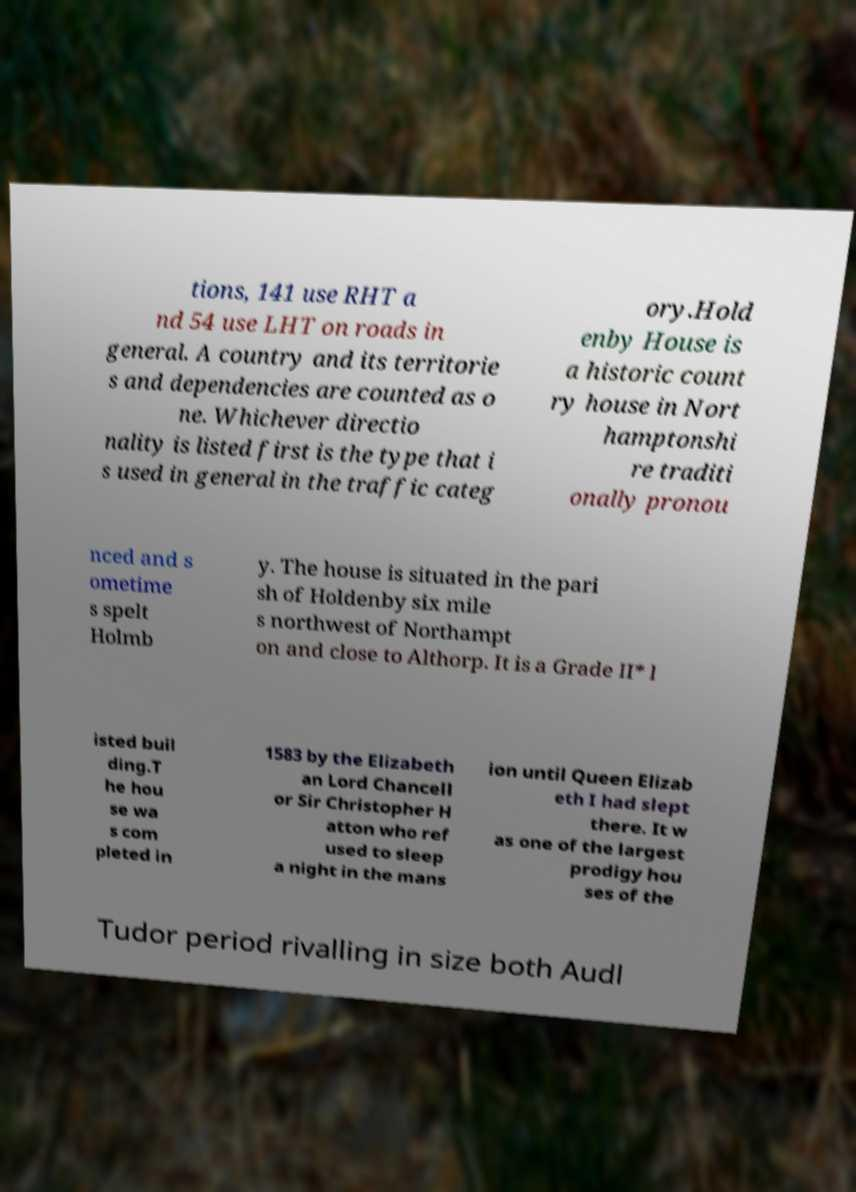For documentation purposes, I need the text within this image transcribed. Could you provide that? tions, 141 use RHT a nd 54 use LHT on roads in general. A country and its territorie s and dependencies are counted as o ne. Whichever directio nality is listed first is the type that i s used in general in the traffic categ ory.Hold enby House is a historic count ry house in Nort hamptonshi re traditi onally pronou nced and s ometime s spelt Holmb y. The house is situated in the pari sh of Holdenby six mile s northwest of Northampt on and close to Althorp. It is a Grade II* l isted buil ding.T he hou se wa s com pleted in 1583 by the Elizabeth an Lord Chancell or Sir Christopher H atton who ref used to sleep a night in the mans ion until Queen Elizab eth I had slept there. It w as one of the largest prodigy hou ses of the Tudor period rivalling in size both Audl 